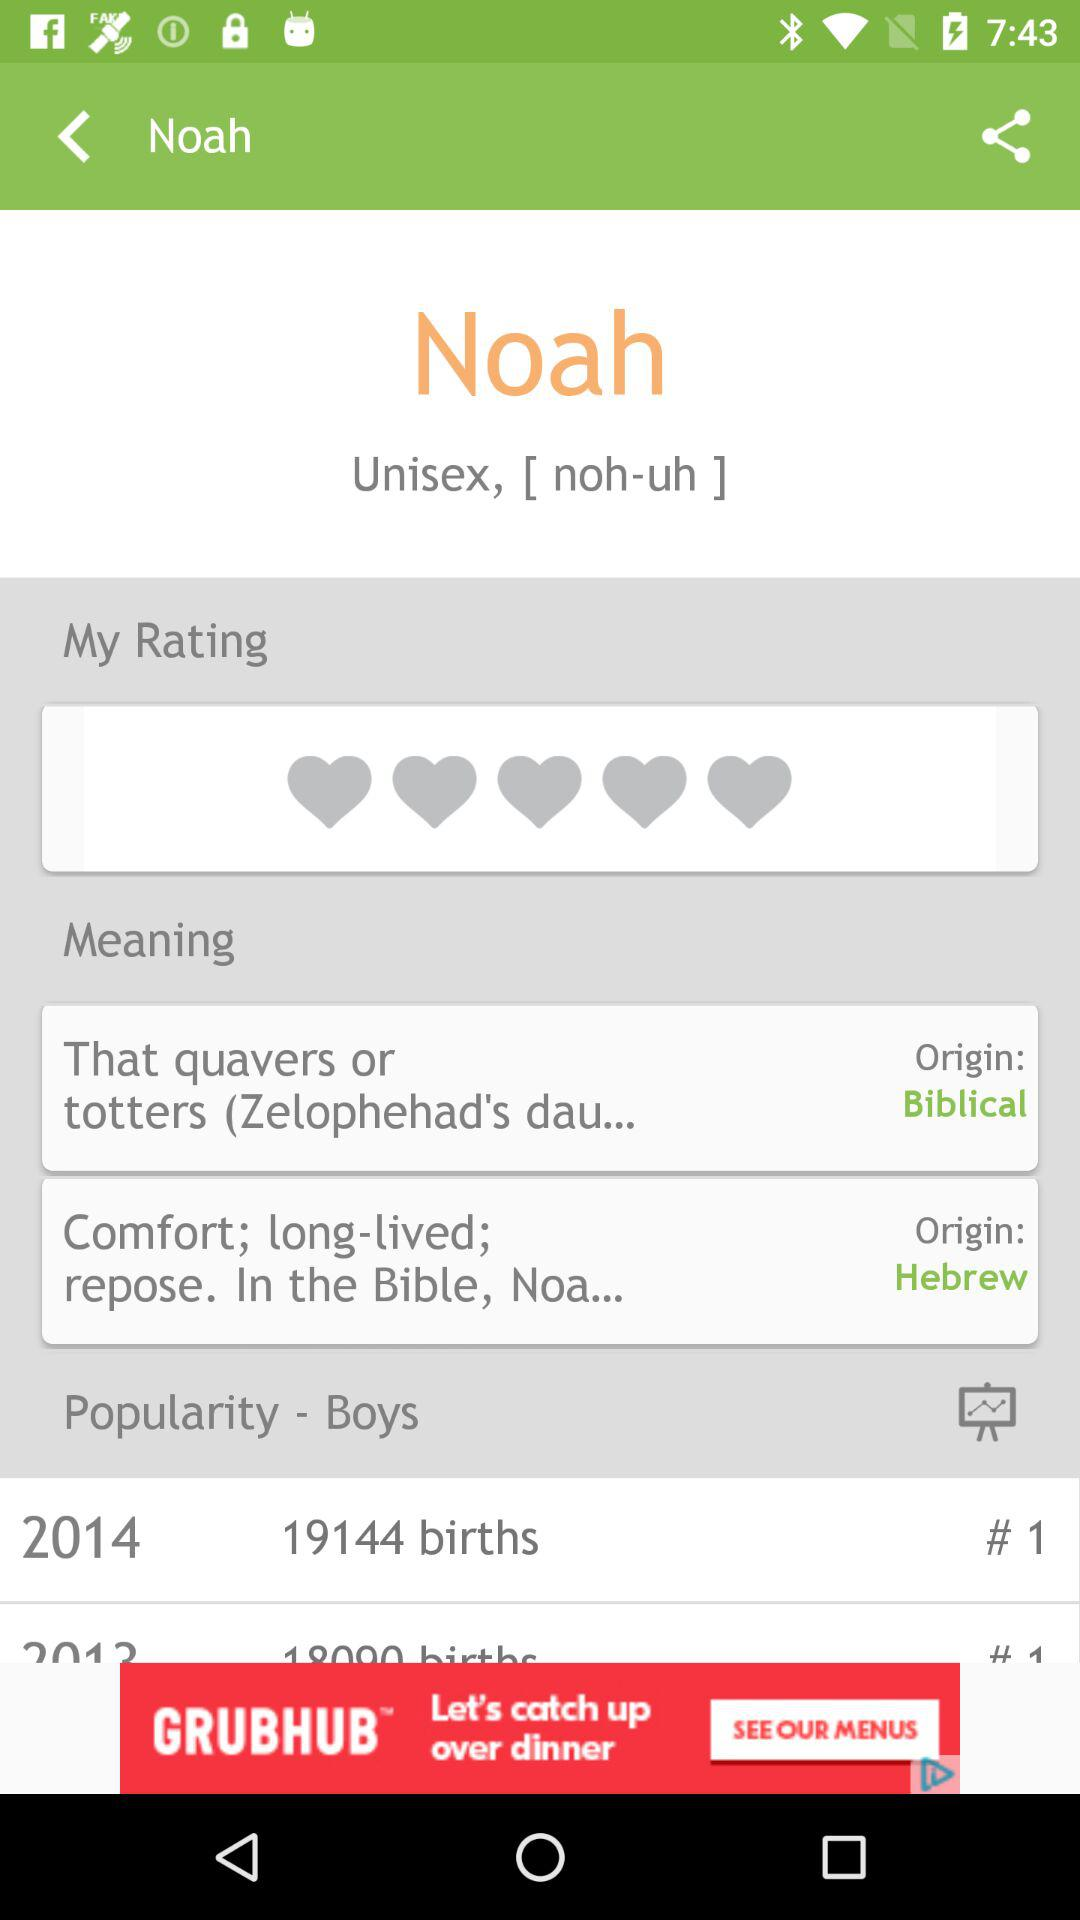Hebrew belons to whom?
When the provided information is insufficient, respond with <no answer>. <no answer> 